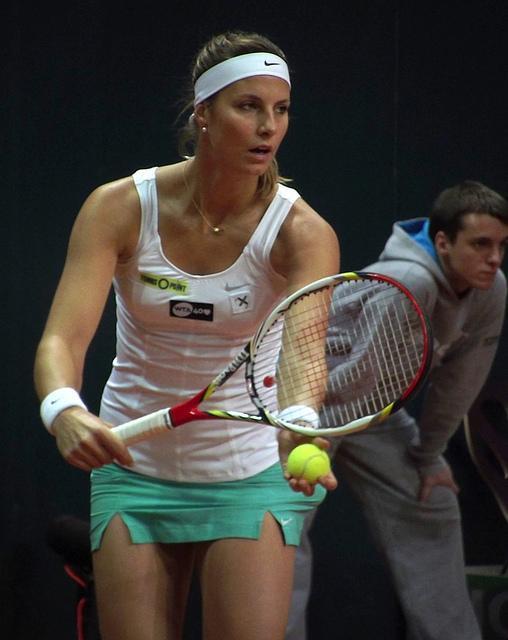How many people are there?
Give a very brief answer. 2. 